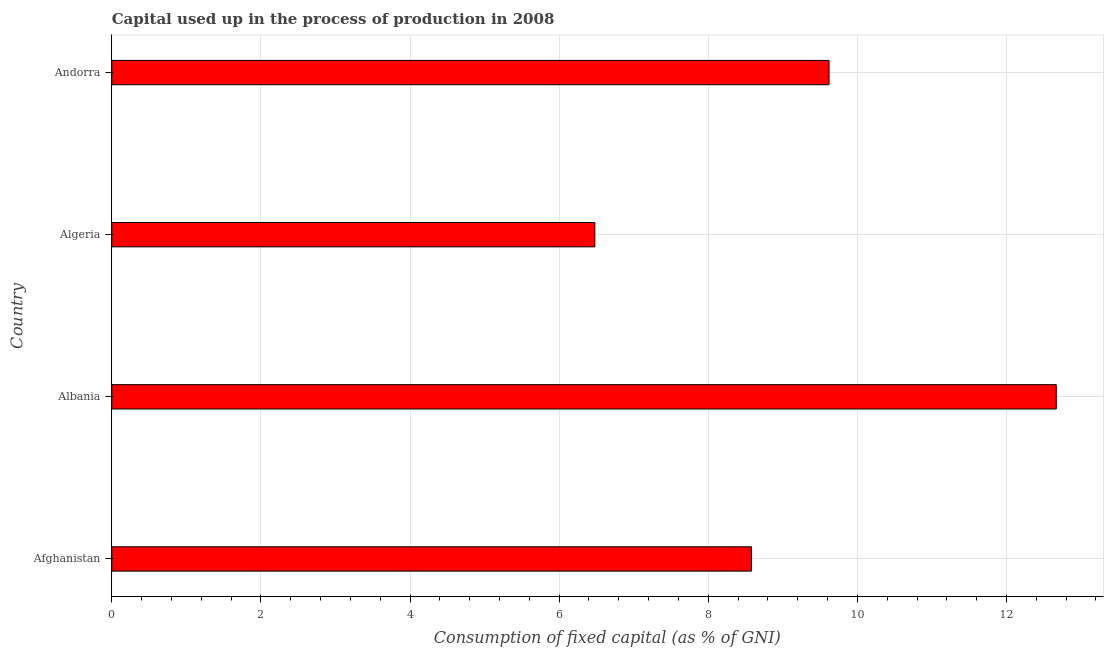Does the graph contain any zero values?
Offer a terse response. No. What is the title of the graph?
Your answer should be very brief. Capital used up in the process of production in 2008. What is the label or title of the X-axis?
Your answer should be compact. Consumption of fixed capital (as % of GNI). What is the consumption of fixed capital in Algeria?
Offer a terse response. 6.48. Across all countries, what is the maximum consumption of fixed capital?
Offer a terse response. 12.67. Across all countries, what is the minimum consumption of fixed capital?
Offer a terse response. 6.48. In which country was the consumption of fixed capital maximum?
Make the answer very short. Albania. In which country was the consumption of fixed capital minimum?
Your answer should be compact. Algeria. What is the sum of the consumption of fixed capital?
Offer a very short reply. 37.35. What is the difference between the consumption of fixed capital in Afghanistan and Andorra?
Provide a succinct answer. -1.04. What is the average consumption of fixed capital per country?
Your answer should be very brief. 9.34. What is the median consumption of fixed capital?
Give a very brief answer. 9.1. In how many countries, is the consumption of fixed capital greater than 1.6 %?
Keep it short and to the point. 4. What is the ratio of the consumption of fixed capital in Algeria to that in Andorra?
Give a very brief answer. 0.67. Is the difference between the consumption of fixed capital in Afghanistan and Albania greater than the difference between any two countries?
Give a very brief answer. No. What is the difference between the highest and the second highest consumption of fixed capital?
Provide a succinct answer. 3.05. Is the sum of the consumption of fixed capital in Albania and Andorra greater than the maximum consumption of fixed capital across all countries?
Your answer should be very brief. Yes. What is the difference between the highest and the lowest consumption of fixed capital?
Provide a short and direct response. 6.19. How many bars are there?
Your response must be concise. 4. What is the difference between two consecutive major ticks on the X-axis?
Give a very brief answer. 2. Are the values on the major ticks of X-axis written in scientific E-notation?
Offer a terse response. No. What is the Consumption of fixed capital (as % of GNI) in Afghanistan?
Ensure brevity in your answer.  8.58. What is the Consumption of fixed capital (as % of GNI) in Albania?
Give a very brief answer. 12.67. What is the Consumption of fixed capital (as % of GNI) in Algeria?
Keep it short and to the point. 6.48. What is the Consumption of fixed capital (as % of GNI) of Andorra?
Offer a very short reply. 9.62. What is the difference between the Consumption of fixed capital (as % of GNI) in Afghanistan and Albania?
Offer a very short reply. -4.09. What is the difference between the Consumption of fixed capital (as % of GNI) in Afghanistan and Algeria?
Offer a terse response. 2.1. What is the difference between the Consumption of fixed capital (as % of GNI) in Afghanistan and Andorra?
Your answer should be compact. -1.04. What is the difference between the Consumption of fixed capital (as % of GNI) in Albania and Algeria?
Your answer should be compact. 6.19. What is the difference between the Consumption of fixed capital (as % of GNI) in Albania and Andorra?
Provide a short and direct response. 3.05. What is the difference between the Consumption of fixed capital (as % of GNI) in Algeria and Andorra?
Ensure brevity in your answer.  -3.14. What is the ratio of the Consumption of fixed capital (as % of GNI) in Afghanistan to that in Albania?
Give a very brief answer. 0.68. What is the ratio of the Consumption of fixed capital (as % of GNI) in Afghanistan to that in Algeria?
Offer a very short reply. 1.32. What is the ratio of the Consumption of fixed capital (as % of GNI) in Afghanistan to that in Andorra?
Offer a terse response. 0.89. What is the ratio of the Consumption of fixed capital (as % of GNI) in Albania to that in Algeria?
Your response must be concise. 1.96. What is the ratio of the Consumption of fixed capital (as % of GNI) in Albania to that in Andorra?
Offer a very short reply. 1.32. What is the ratio of the Consumption of fixed capital (as % of GNI) in Algeria to that in Andorra?
Ensure brevity in your answer.  0.67. 